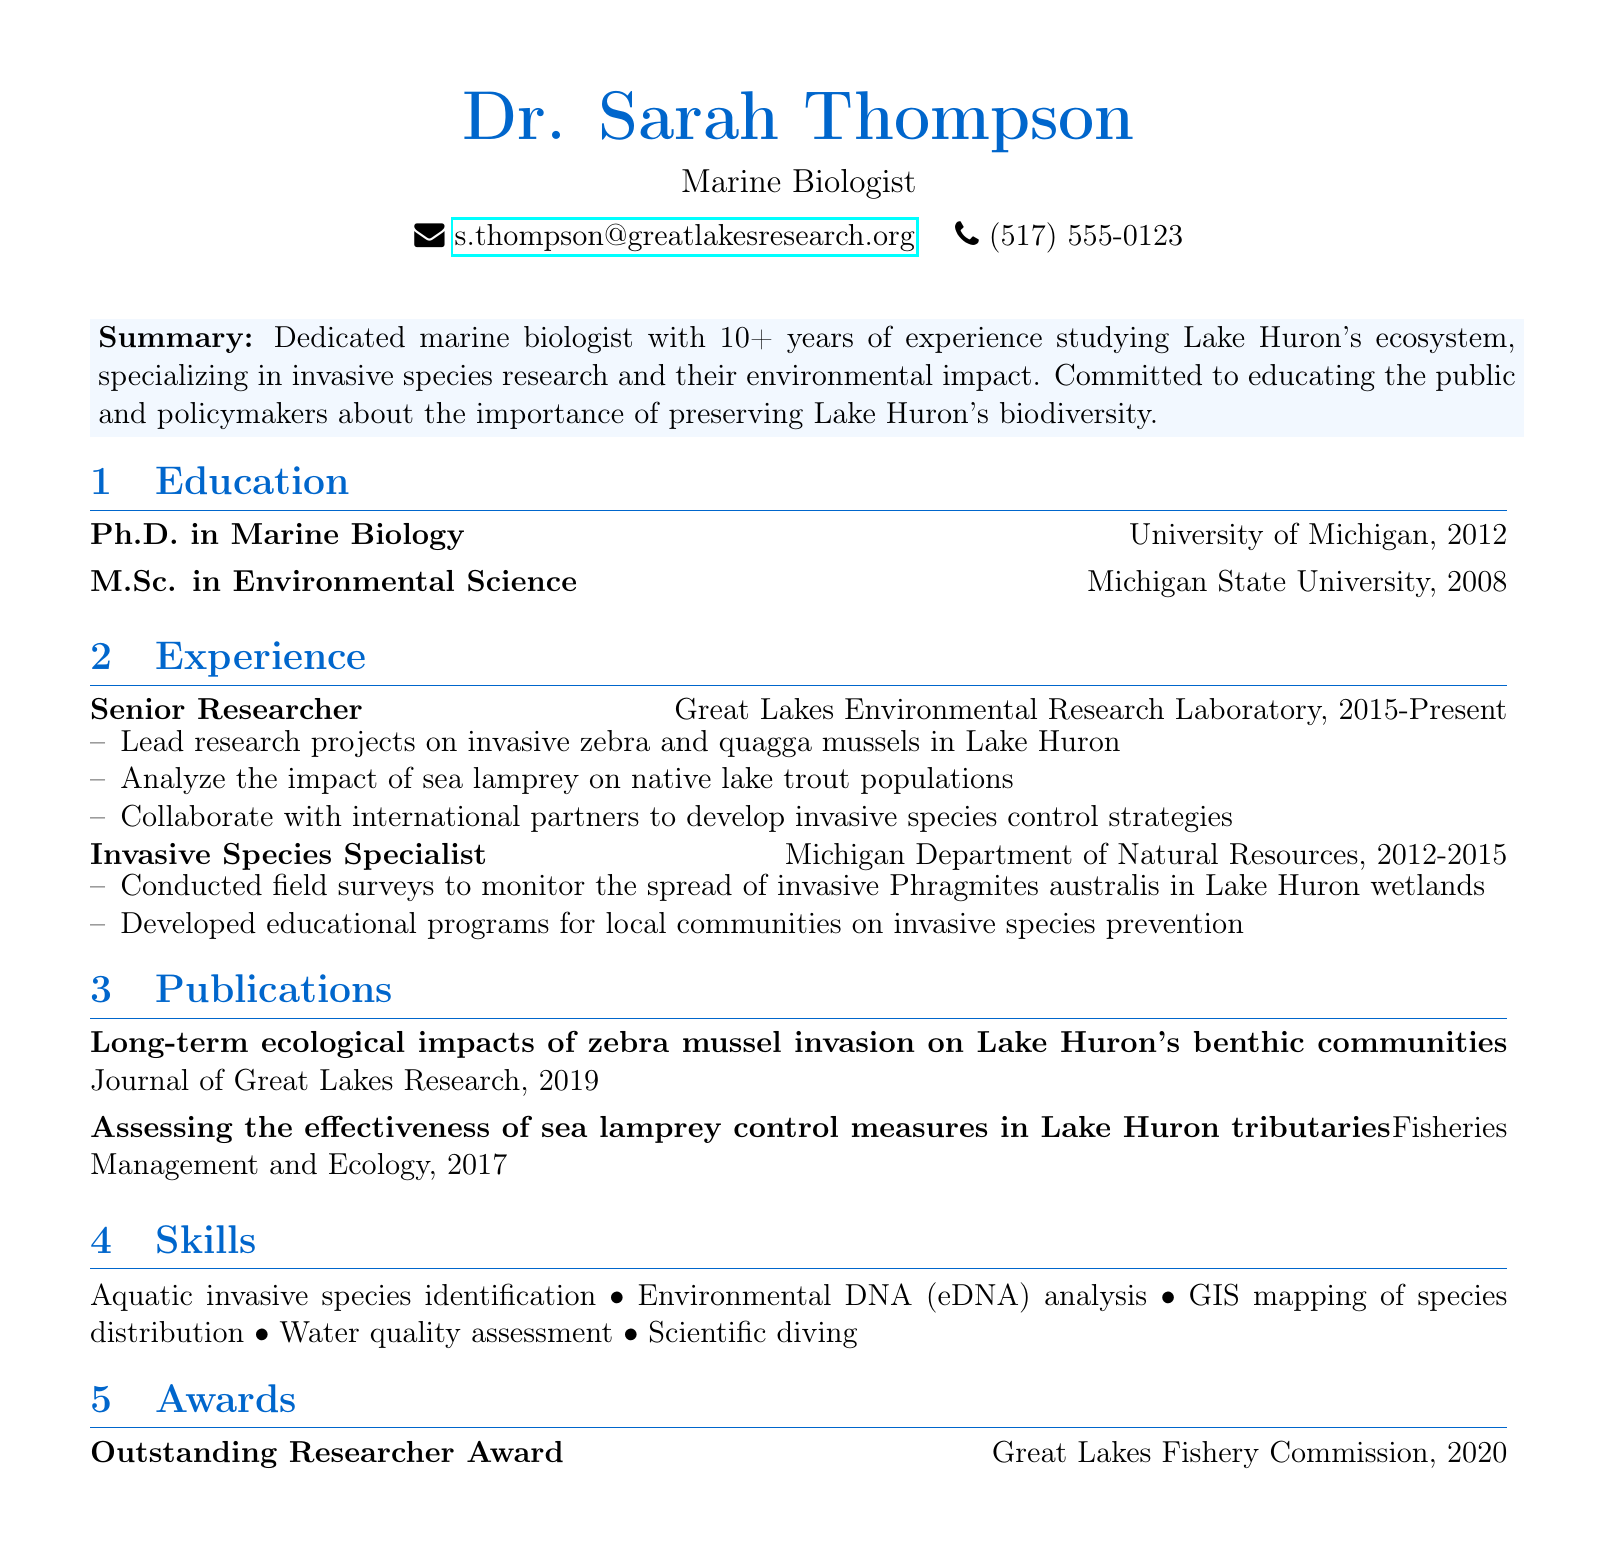What is Dr. Sarah Thompson's title? The title listed in the document is "Marine Biologist."
Answer: Marine Biologist What year did Dr. Thompson obtain her Ph.D.? The document states that her Ph.D. was awarded in 2012.
Answer: 2012 Which organization does Dr. Thompson currently work for? The document indicates that she is a Senior Researcher at the Great Lakes Environmental Research Laboratory.
Answer: Great Lakes Environmental Research Laboratory What invasive species did Dr. Thompson focus on at the Michigan Department of Natural Resources? The document lists Phragmites australis as an invasive species she monitored.
Answer: Phragmites australis In what year was Dr. Thompson awarded the Outstanding Researcher Award? The award year mentioned in the document is 2020.
Answer: 2020 What skill related to species distribution does Dr. Thompson have? The document mentions GIS mapping of species distribution as one of her skills.
Answer: GIS mapping of species distribution What is the title of Dr. Thompson's publication about zebra mussels? The document refers to "Long-term ecological impacts of zebra mussel invasion on Lake Huron's benthic communities."
Answer: Long-term ecological impacts of zebra mussel invasion on Lake Huron's benthic communities Which university did Dr. Thompson attend for her Master's degree? The document states that she attended Michigan State University for her M.Sc.
Answer: Michigan State University 